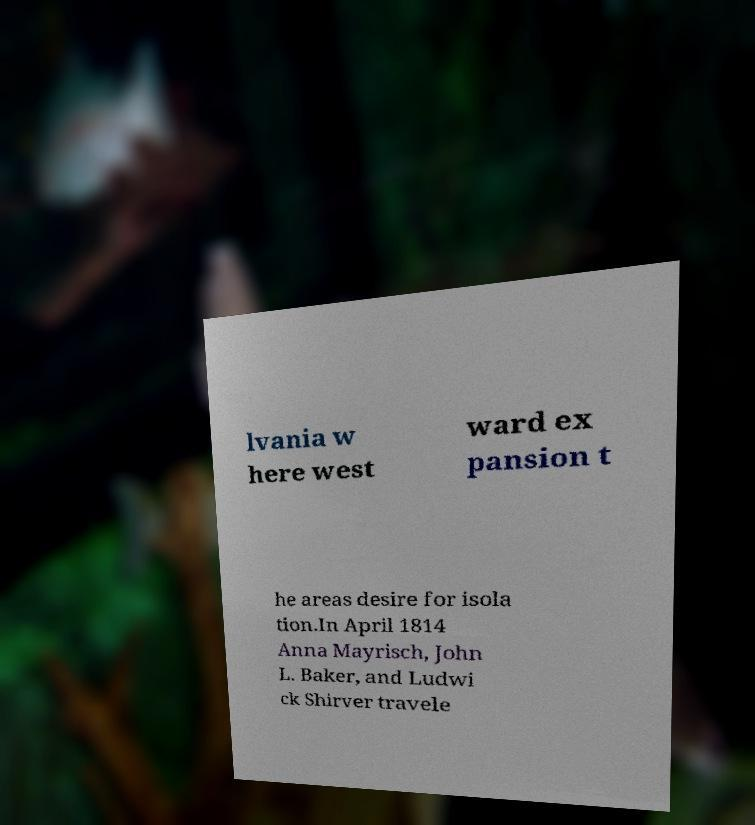Can you accurately transcribe the text from the provided image for me? lvania w here west ward ex pansion t he areas desire for isola tion.In April 1814 Anna Mayrisch, John L. Baker, and Ludwi ck Shirver travele 